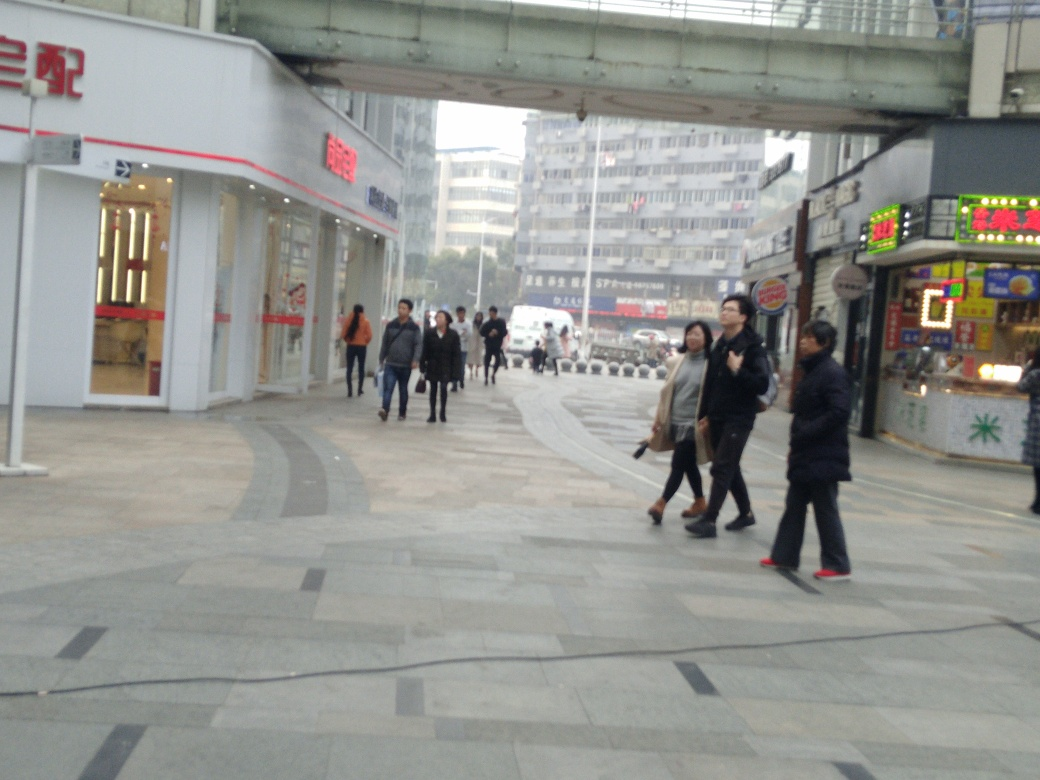What might be the time of day in this image? Based on the lighting and the activity level, it seems to be daytime, likely late morning or early afternoon, as people are out and businesses are open, but shadows are not very pronounced, suggesting the sun isn't at its zenith. 